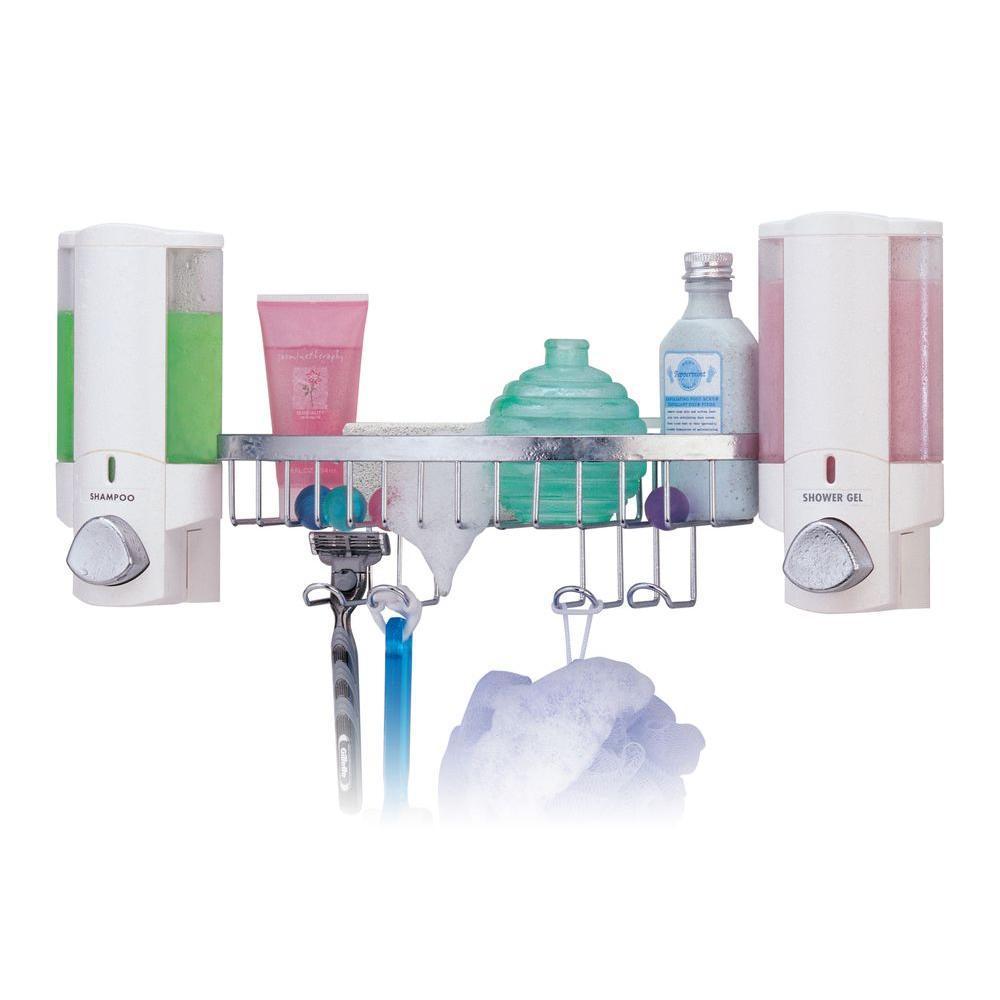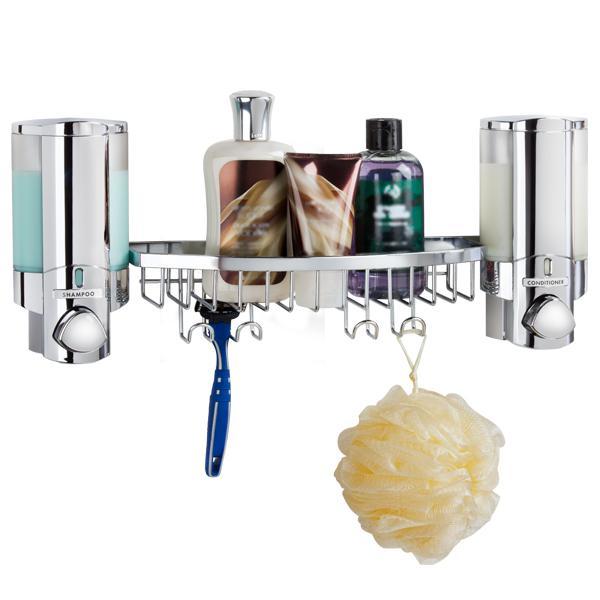The first image is the image on the left, the second image is the image on the right. Analyze the images presented: Is the assertion "Each image contains at least three dispensers in a line." valid? Answer yes or no. No. The first image is the image on the left, the second image is the image on the right. Analyze the images presented: Is the assertion "At least one image shows a chrome rack with a suspended round scrubber, between two dispensers." valid? Answer yes or no. Yes. 